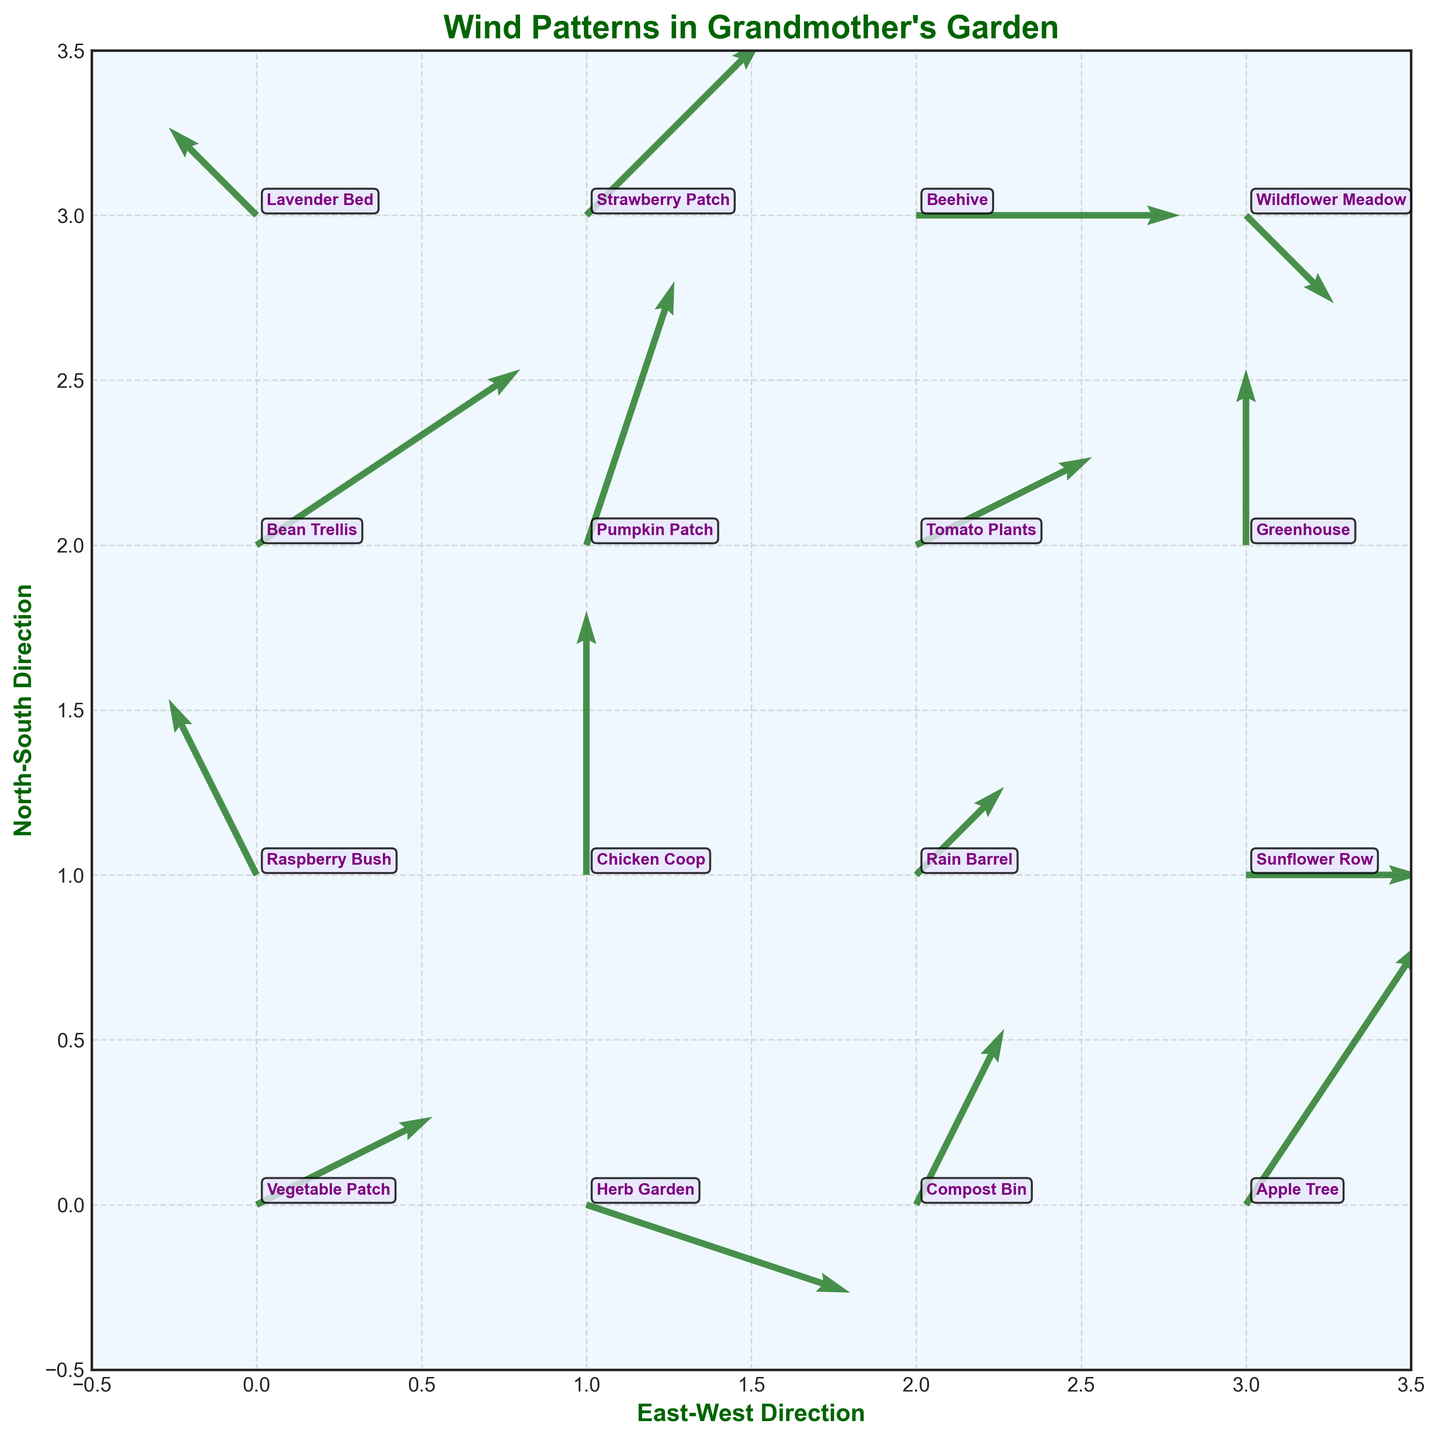What does the title of the quiver plot indicate? The title of the quiver plot is "Wind Patterns in Grandmother's Garden" which suggests that the plot shows the direction and speed of wind across different locations in the garden.
Answer: Wind Patterns in Grandmother's Garden How many data points are represented in the quiver plot? Each marking on the plot, along with its arrow, represents a data point. Since the dataset has 16 different garden locations, the quiver plot also has 16 data points.
Answer: 16 What does the arrow direction and length represent in the quiver plot? In a quiver plot, the direction of the arrow shows the direction of the wind and the length of the arrow indicates the speed of the wind at each location. Longer arrows represent higher wind speeds and the arrow's angle shows the direction.
Answer: Wind direction and speed Which location has the greatest eastward velocity? Look for the longest arrow pointing directly to the right (east). The location with vector (3, 2) indicating the longest eastward velocity is "Bean Trellis."
Answer: Bean Trellis What are the wind velocities at the "Tomato Plants" location? Find the label "Tomato Plants" on the plot and note the arrow's length and direction. The velocity components provided are 2 units east and 1 unit north (U=2, V=1).
Answer: East: 2, North: 1 Which location has wind moving directly north with no east or west component? Locate the position where the U component (east-west direction) is 0 and the V component (north-south direction) is positive. The "Chicken Coop" has no east-west component and moves directly north with vector (U=0, V=3).
Answer: Chicken Coop Compare the wind speeds at "Wildflower Meadow" and "Strawberry Patch" – which one is faster? Calculate the magnitude of wind velocity vectors for both. For "Wildflower Meadow" (1, -1): sqrt(1^2 + (-1)^2) = sqrt(2). For "Strawberry Patch" (2, 2): sqrt(2^2 + 2^2) = sqrt(8). "Strawberry Patch" has the higher wind speed.
Answer: Strawberry Patch Between the "Apple Tree" and "Herb Garden", which has the wind blowing more northward? Compare their northward (V) components. "Apple Tree" has a V value of 3 and "Herb Garden" has a V value of -1. Hence, "Apple Tree" has more northward blowing wind.
Answer: Apple Tree What is the average magnitude of the wind velocity vectors across all locations? Calculate magnitudes for each vector: sqrt(U^2 + V^2), sum them, and divide by the number of points. Velocities: sqrt(5), sqrt(10), sqrt(5), sqrt(13), sqrt(5), sqrt(9), sqrt(2), sqrt(4), sqrt(13), sqrt(10), sqrt(5), sqrt(4), sqrt(2), sqrt(8), sqrt(9), sqrt(2). Sum=33.79. Average = 33.79 / 16 ≈ 2.11.
Answer: 2.11 